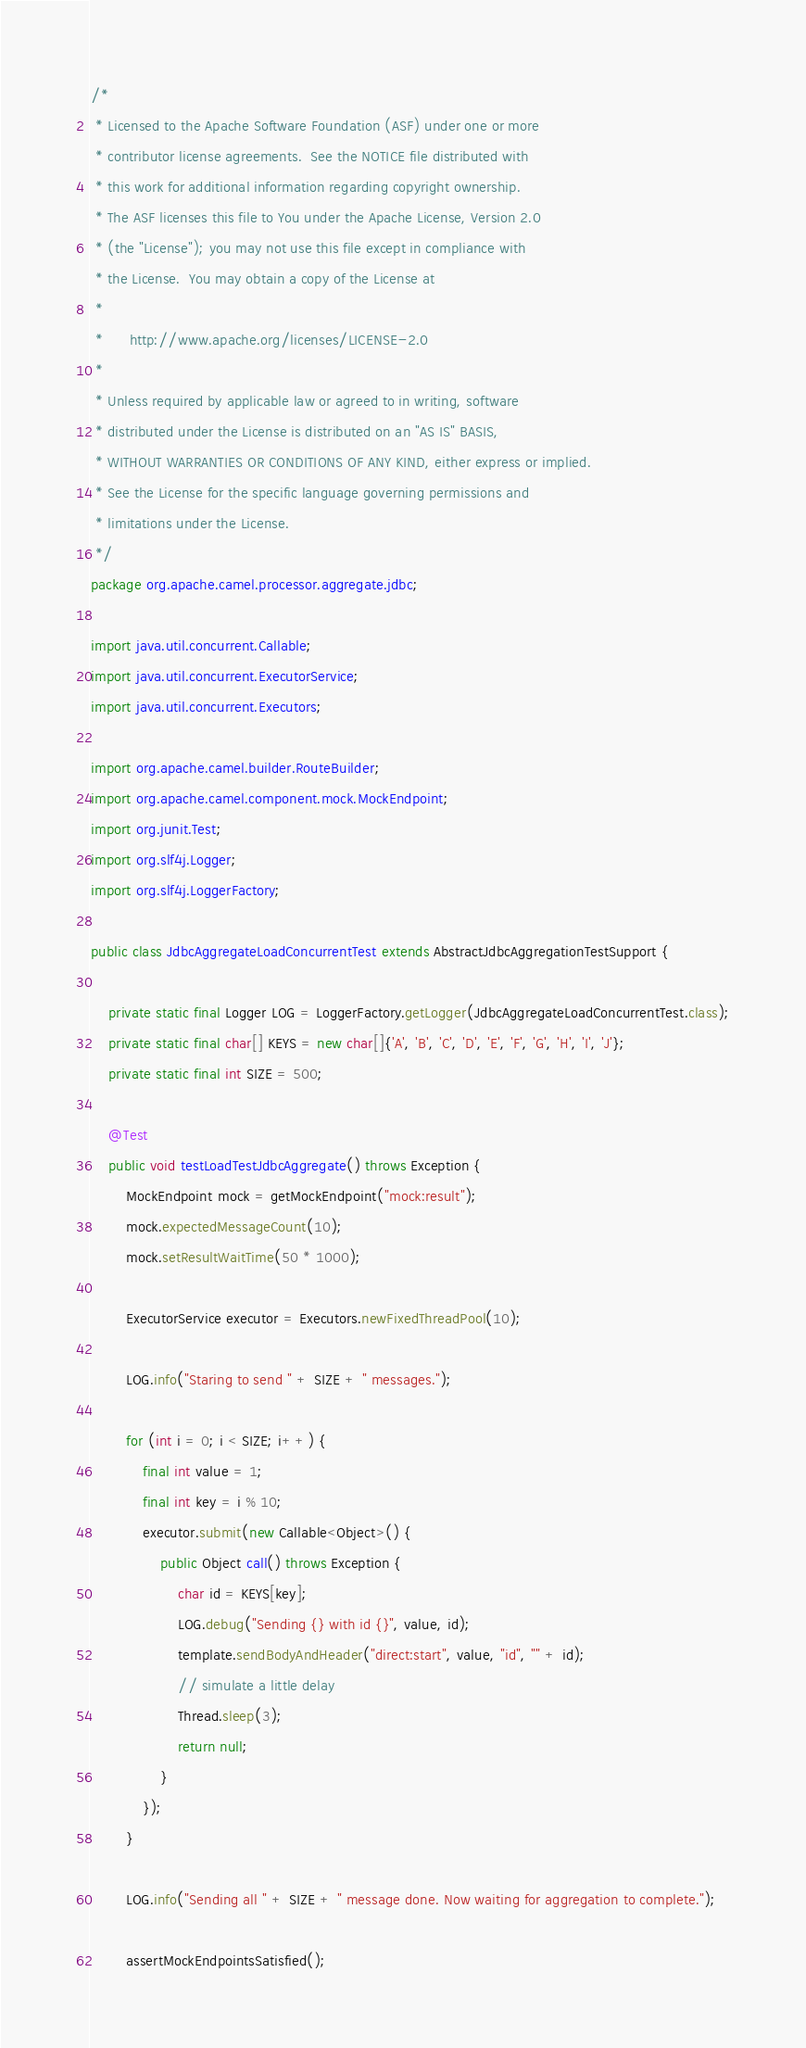Convert code to text. <code><loc_0><loc_0><loc_500><loc_500><_Java_>/*
 * Licensed to the Apache Software Foundation (ASF) under one or more
 * contributor license agreements.  See the NOTICE file distributed with
 * this work for additional information regarding copyright ownership.
 * The ASF licenses this file to You under the Apache License, Version 2.0
 * (the "License"); you may not use this file except in compliance with
 * the License.  You may obtain a copy of the License at
 *
 *      http://www.apache.org/licenses/LICENSE-2.0
 *
 * Unless required by applicable law or agreed to in writing, software
 * distributed under the License is distributed on an "AS IS" BASIS,
 * WITHOUT WARRANTIES OR CONDITIONS OF ANY KIND, either express or implied.
 * See the License for the specific language governing permissions and
 * limitations under the License.
 */
package org.apache.camel.processor.aggregate.jdbc;

import java.util.concurrent.Callable;
import java.util.concurrent.ExecutorService;
import java.util.concurrent.Executors;

import org.apache.camel.builder.RouteBuilder;
import org.apache.camel.component.mock.MockEndpoint;
import org.junit.Test;
import org.slf4j.Logger;
import org.slf4j.LoggerFactory;

public class JdbcAggregateLoadConcurrentTest extends AbstractJdbcAggregationTestSupport {

    private static final Logger LOG = LoggerFactory.getLogger(JdbcAggregateLoadConcurrentTest.class);
    private static final char[] KEYS = new char[]{'A', 'B', 'C', 'D', 'E', 'F', 'G', 'H', 'I', 'J'};
    private static final int SIZE = 500;

    @Test
    public void testLoadTestJdbcAggregate() throws Exception {
        MockEndpoint mock = getMockEndpoint("mock:result");
        mock.expectedMessageCount(10);
        mock.setResultWaitTime(50 * 1000);

        ExecutorService executor = Executors.newFixedThreadPool(10);

        LOG.info("Staring to send " + SIZE + " messages.");

        for (int i = 0; i < SIZE; i++) {
            final int value = 1;
            final int key = i % 10;
            executor.submit(new Callable<Object>() {
                public Object call() throws Exception {
                    char id = KEYS[key];
                    LOG.debug("Sending {} with id {}", value, id);
                    template.sendBodyAndHeader("direct:start", value, "id", "" + id);
                    // simulate a little delay
                    Thread.sleep(3);
                    return null;
                }
            });
        }

        LOG.info("Sending all " + SIZE + " message done. Now waiting for aggregation to complete.");

        assertMockEndpointsSatisfied();</code> 